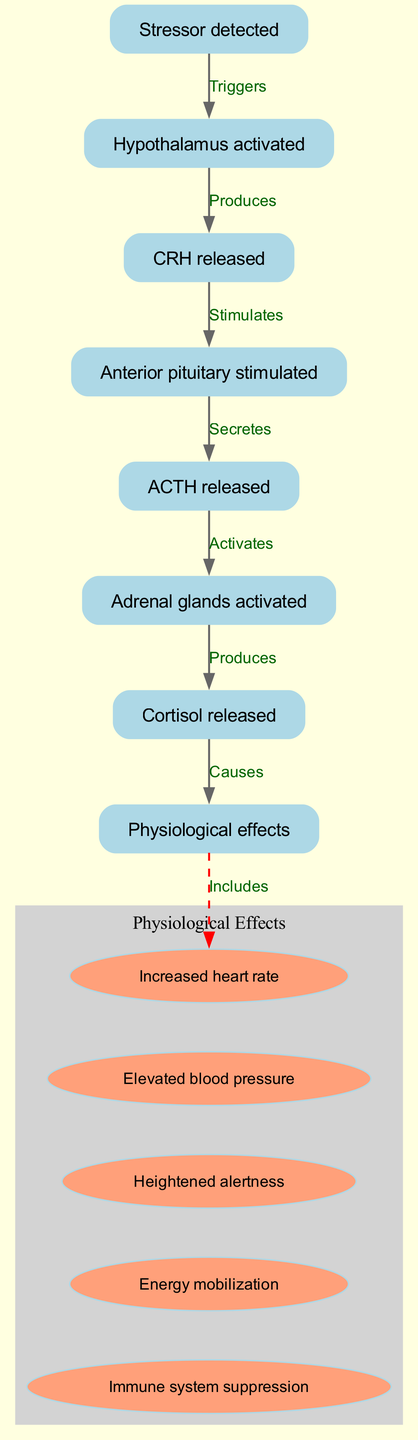What is the initial trigger for the human stress response pathway? The initial trigger is the detection of a stressor, which activates the hypothalamus. This is the first step shown in the diagram, linking the "Stressor detected" node directly to the "Hypothalamus activated" node.
Answer: Stressor detected How many nodes are present in the diagram? Counting all the unique nodes in the diagram, we have a total of eight nodes. This includes "Stressor detected," "Hypothalamus activated," "CRH released," "Anterior pituitary stimulated," "ACTH released," "Adrenal glands activated," "Cortisol released," and "Physiological effects."
Answer: 8 What hormone is released after the activation of the anterior pituitary? The anterior pituitary releases ACTH, as indicated by the direct connection from "Anterior pituitary stimulated" to "ACTH released." This relationship is clearly labeled in the diagram.
Answer: ACTH released What does cortisol cause in the body? The diagram states that cortisol causes various physiological effects, shown as a connection that starts from "Cortisol released" and leads to "Physiological effects." This indicates that cortisol plays a key role in initiating these effects.
Answer: Physiological effects How many physiological effects are listed in the diagram? The diagram specifies five physiological effects, which are grouped under the "Physiological Effects" cluster. Each effect is represented as an individual node connected to the main "effects" node.
Answer: 5 What is the role of CRH in the stress response pathway? CRH is released by the activated hypothalamus and serves to stimulate the anterior pituitary, as shown by the arrow labeled "Stimulates" from the "CRH released" node to the "Anterior pituitary stimulated" node. Thus, CRH initiates the cascade that leads to the release of ACTH.
Answer: Stimulates Which gland is activated by ACTH? The adrenal glands are activated by ACTH, which is indicated in the diagram where the edge is labeled "Activates," connecting "ACTH released" to "Adrenal glands activated." This shows the direct relationship between these two nodes.
Answer: Adrenal glands activated What type of effects does cortisol primarily promote? The diagram indicates that cortisol primarily promotes physiological effects, as shown by the connection leading from "Cortisol released" to "Physiological effects," implying a range of responses triggered by cortisol in the body.
Answer: Physiological effects 